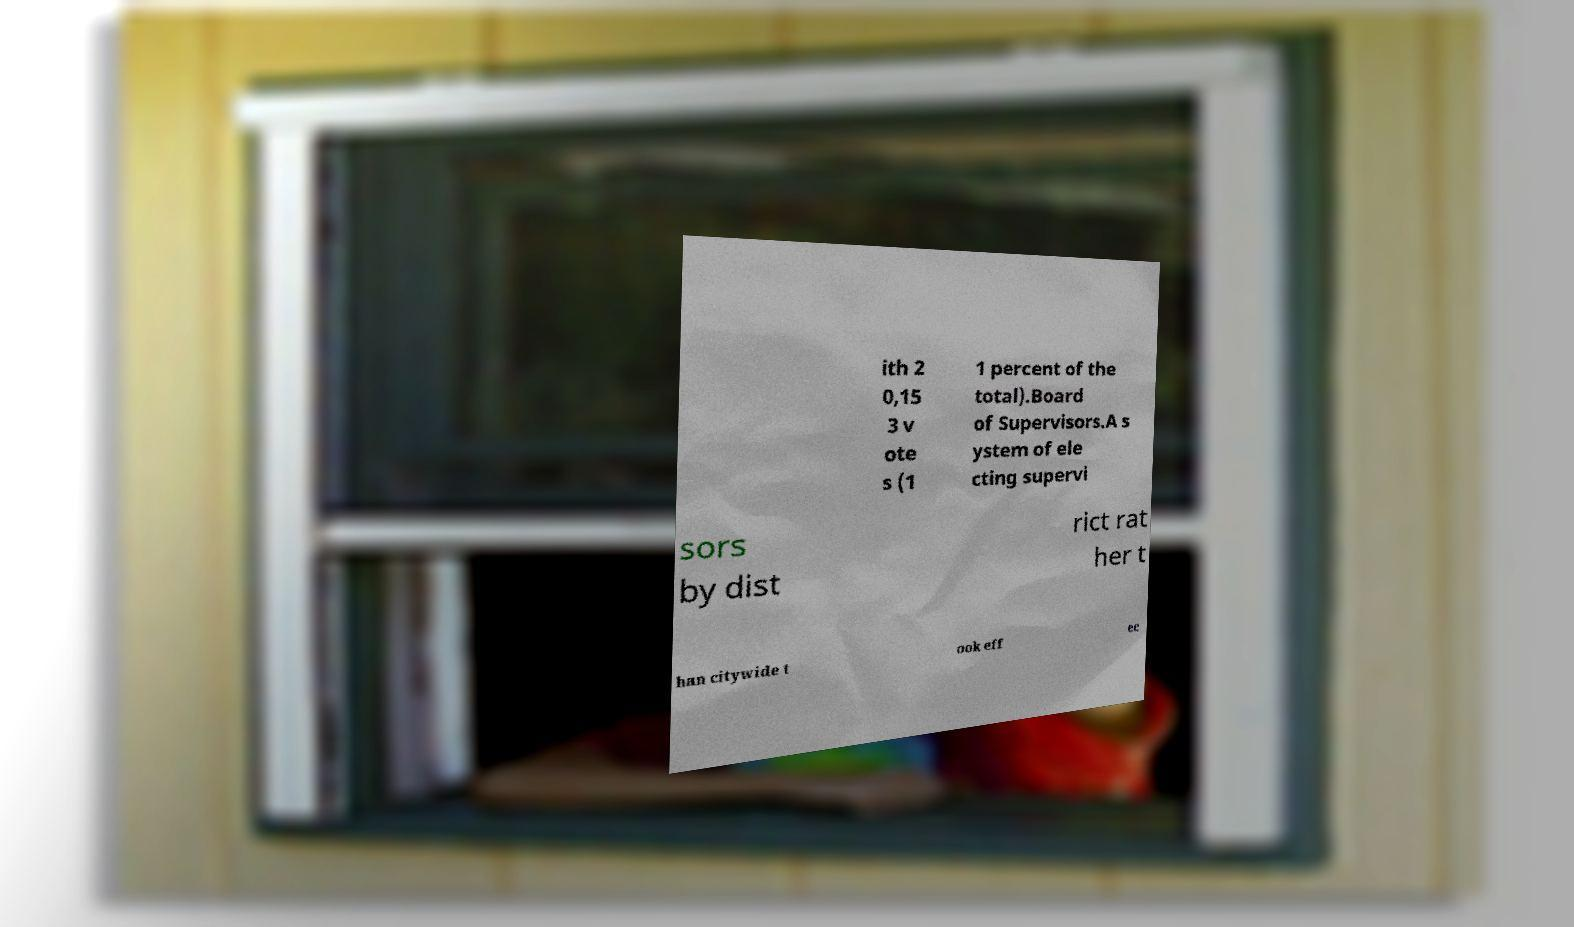There's text embedded in this image that I need extracted. Can you transcribe it verbatim? ith 2 0,15 3 v ote s (1 1 percent of the total).Board of Supervisors.A s ystem of ele cting supervi sors by dist rict rat her t han citywide t ook eff ec 